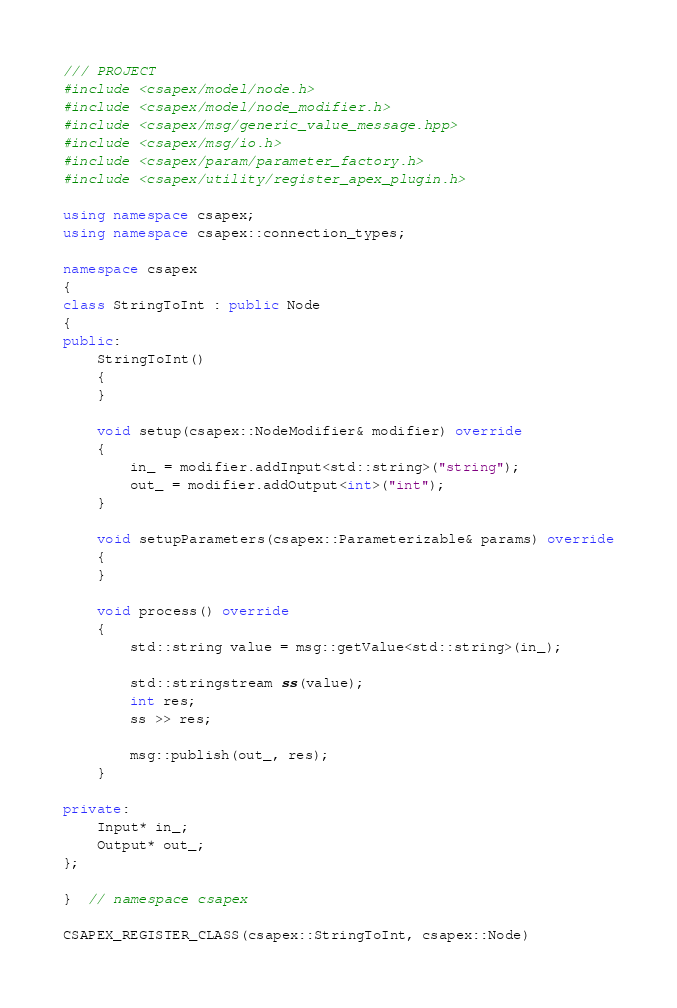Convert code to text. <code><loc_0><loc_0><loc_500><loc_500><_C++_>
/// PROJECT
#include <csapex/model/node.h>
#include <csapex/model/node_modifier.h>
#include <csapex/msg/generic_value_message.hpp>
#include <csapex/msg/io.h>
#include <csapex/param/parameter_factory.h>
#include <csapex/utility/register_apex_plugin.h>

using namespace csapex;
using namespace csapex::connection_types;

namespace csapex
{
class StringToInt : public Node
{
public:
    StringToInt()
    {
    }

    void setup(csapex::NodeModifier& modifier) override
    {
        in_ = modifier.addInput<std::string>("string");
        out_ = modifier.addOutput<int>("int");
    }

    void setupParameters(csapex::Parameterizable& params) override
    {
    }

    void process() override
    {
        std::string value = msg::getValue<std::string>(in_);

        std::stringstream ss(value);
        int res;
        ss >> res;

        msg::publish(out_, res);
    }

private:
    Input* in_;
    Output* out_;
};

}  // namespace csapex

CSAPEX_REGISTER_CLASS(csapex::StringToInt, csapex::Node)
</code> 